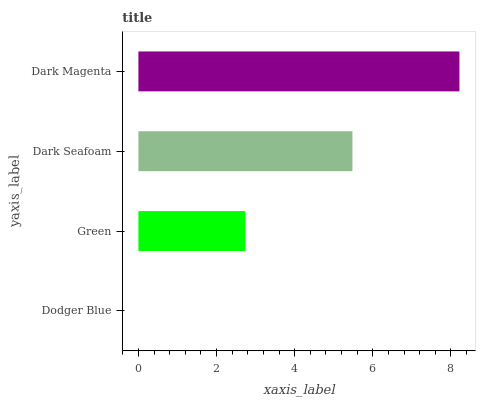Is Dodger Blue the minimum?
Answer yes or no. Yes. Is Dark Magenta the maximum?
Answer yes or no. Yes. Is Green the minimum?
Answer yes or no. No. Is Green the maximum?
Answer yes or no. No. Is Green greater than Dodger Blue?
Answer yes or no. Yes. Is Dodger Blue less than Green?
Answer yes or no. Yes. Is Dodger Blue greater than Green?
Answer yes or no. No. Is Green less than Dodger Blue?
Answer yes or no. No. Is Dark Seafoam the high median?
Answer yes or no. Yes. Is Green the low median?
Answer yes or no. Yes. Is Green the high median?
Answer yes or no. No. Is Dark Seafoam the low median?
Answer yes or no. No. 